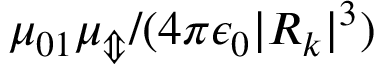Convert formula to latex. <formula><loc_0><loc_0><loc_500><loc_500>\mu _ { 0 1 } \mu _ { \Updownarrow } / ( 4 \pi \epsilon _ { 0 } | R _ { k } | ^ { 3 } )</formula> 